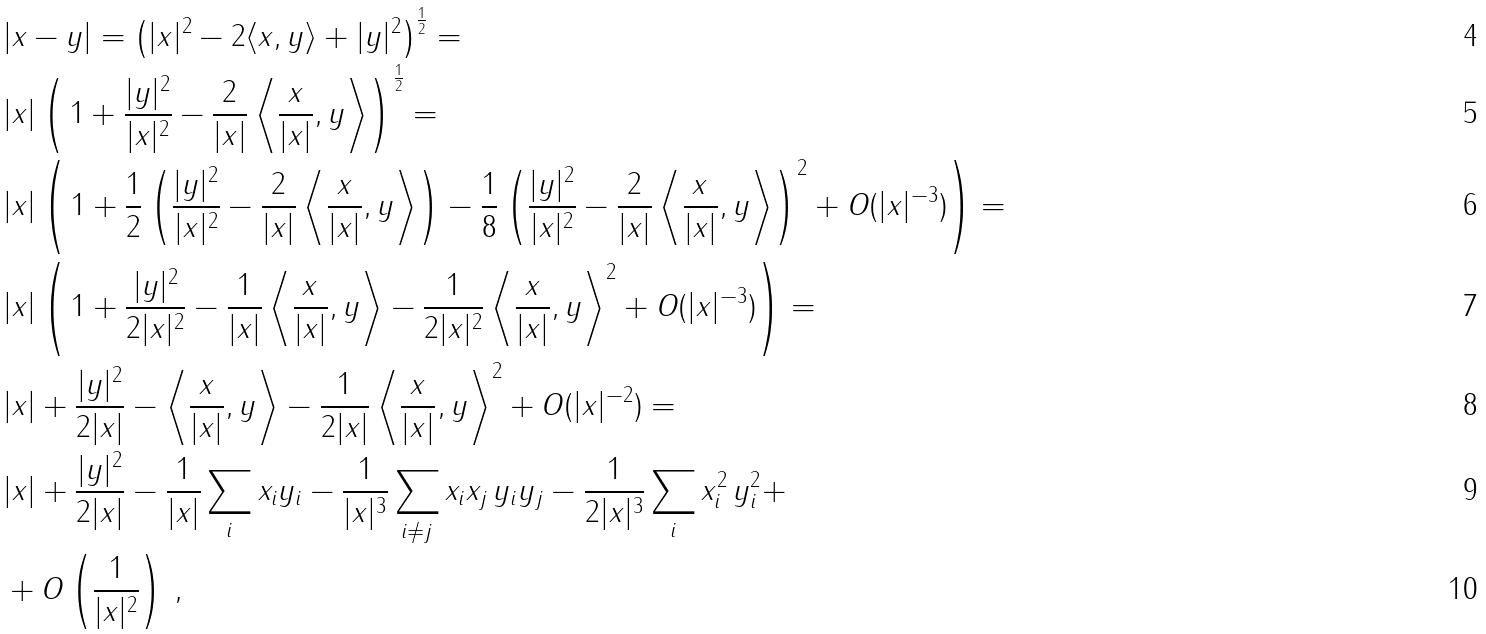<formula> <loc_0><loc_0><loc_500><loc_500>& | x - y | = \left ( | x | ^ { 2 } - 2 \langle x , y \rangle + | y | ^ { 2 } \right ) ^ { \frac { 1 } { 2 } } = \\ & | x | \left ( \, 1 + \frac { | y | ^ { 2 } } { | x | ^ { 2 } } - \frac { 2 } { | x | } \left \langle \frac { x } { | x | } , y \right \rangle \right ) ^ { \frac { 1 } { 2 } } = \\ & | x | \left ( \, 1 + \frac { 1 } { 2 } \left ( \frac { | y | ^ { 2 } } { | x | ^ { 2 } } - \frac { 2 } { | x | } \left \langle \frac { x } { | x | } , y \right \rangle \right ) - \frac { 1 } { 8 } \left ( \frac { | y | ^ { 2 } } { | x | ^ { 2 } } - \frac { 2 } { | x | } \left \langle \frac { x } { | x | } , y \right \rangle \right ) ^ { 2 } + O ( | x | ^ { - 3 } ) \right ) = \\ & | x | \left ( \, 1 + \frac { | y | ^ { 2 } } { 2 | x | ^ { 2 } } - \frac { 1 } { | x | } \left \langle \frac { x } { | x | } , y \right \rangle - \frac { 1 } { 2 | x | ^ { 2 } } \left \langle \frac { x } { | x | } , y \right \rangle ^ { 2 } + O ( | x | ^ { - 3 } ) \right ) = \\ & | x | + \frac { | y | ^ { 2 } } { 2 | x | } - \left \langle \frac { x } { | x | } , y \right \rangle - \frac { 1 } { 2 | x | } \left \langle \frac { x } { | x | } , y \right \rangle ^ { 2 } + O ( | x | ^ { - 2 } ) = \\ & | x | + \frac { | y | ^ { 2 } } { 2 | x | } - \frac { 1 } { | x | } \sum _ { i } x _ { i } y _ { i } - \frac { 1 } { | x | ^ { 3 } } \sum _ { i \neq j } x _ { i } x _ { j } \, y _ { i } y _ { j } - \frac { 1 } { 2 | x | ^ { 3 } } \sum _ { i } x _ { i } ^ { 2 } \, y _ { i } ^ { 2 } + \\ & + O \left ( \frac { 1 } { | x | ^ { 2 } } \right ) \, ,</formula> 